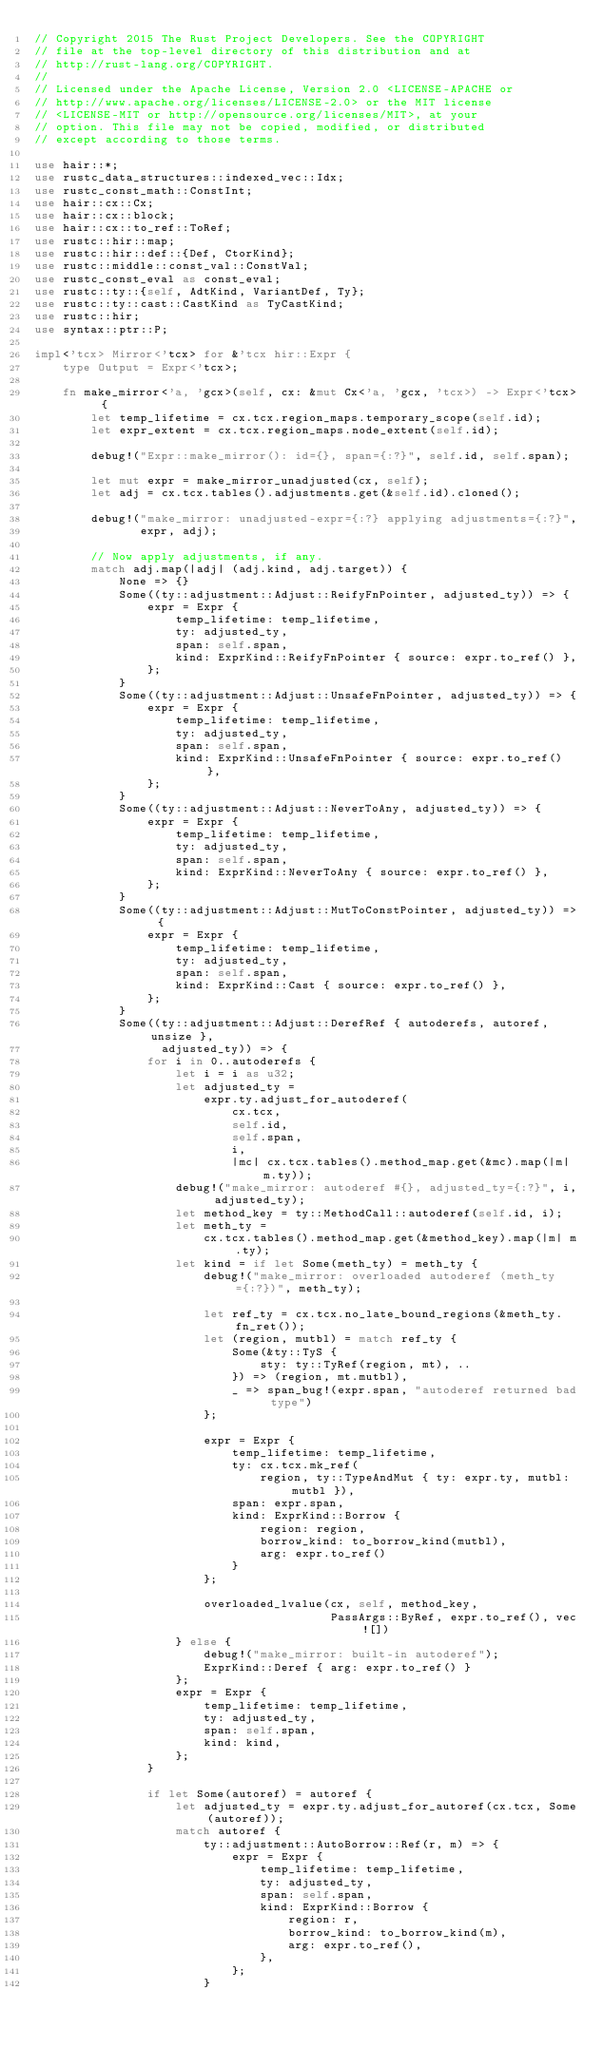Convert code to text. <code><loc_0><loc_0><loc_500><loc_500><_Rust_>// Copyright 2015 The Rust Project Developers. See the COPYRIGHT
// file at the top-level directory of this distribution and at
// http://rust-lang.org/COPYRIGHT.
//
// Licensed under the Apache License, Version 2.0 <LICENSE-APACHE or
// http://www.apache.org/licenses/LICENSE-2.0> or the MIT license
// <LICENSE-MIT or http://opensource.org/licenses/MIT>, at your
// option. This file may not be copied, modified, or distributed
// except according to those terms.

use hair::*;
use rustc_data_structures::indexed_vec::Idx;
use rustc_const_math::ConstInt;
use hair::cx::Cx;
use hair::cx::block;
use hair::cx::to_ref::ToRef;
use rustc::hir::map;
use rustc::hir::def::{Def, CtorKind};
use rustc::middle::const_val::ConstVal;
use rustc_const_eval as const_eval;
use rustc::ty::{self, AdtKind, VariantDef, Ty};
use rustc::ty::cast::CastKind as TyCastKind;
use rustc::hir;
use syntax::ptr::P;

impl<'tcx> Mirror<'tcx> for &'tcx hir::Expr {
    type Output = Expr<'tcx>;

    fn make_mirror<'a, 'gcx>(self, cx: &mut Cx<'a, 'gcx, 'tcx>) -> Expr<'tcx> {
        let temp_lifetime = cx.tcx.region_maps.temporary_scope(self.id);
        let expr_extent = cx.tcx.region_maps.node_extent(self.id);

        debug!("Expr::make_mirror(): id={}, span={:?}", self.id, self.span);

        let mut expr = make_mirror_unadjusted(cx, self);
        let adj = cx.tcx.tables().adjustments.get(&self.id).cloned();

        debug!("make_mirror: unadjusted-expr={:?} applying adjustments={:?}",
               expr, adj);

        // Now apply adjustments, if any.
        match adj.map(|adj| (adj.kind, adj.target)) {
            None => {}
            Some((ty::adjustment::Adjust::ReifyFnPointer, adjusted_ty)) => {
                expr = Expr {
                    temp_lifetime: temp_lifetime,
                    ty: adjusted_ty,
                    span: self.span,
                    kind: ExprKind::ReifyFnPointer { source: expr.to_ref() },
                };
            }
            Some((ty::adjustment::Adjust::UnsafeFnPointer, adjusted_ty)) => {
                expr = Expr {
                    temp_lifetime: temp_lifetime,
                    ty: adjusted_ty,
                    span: self.span,
                    kind: ExprKind::UnsafeFnPointer { source: expr.to_ref() },
                };
            }
            Some((ty::adjustment::Adjust::NeverToAny, adjusted_ty)) => {
                expr = Expr {
                    temp_lifetime: temp_lifetime,
                    ty: adjusted_ty,
                    span: self.span,
                    kind: ExprKind::NeverToAny { source: expr.to_ref() },
                };
            }
            Some((ty::adjustment::Adjust::MutToConstPointer, adjusted_ty)) => {
                expr = Expr {
                    temp_lifetime: temp_lifetime,
                    ty: adjusted_ty,
                    span: self.span,
                    kind: ExprKind::Cast { source: expr.to_ref() },
                };
            }
            Some((ty::adjustment::Adjust::DerefRef { autoderefs, autoref, unsize },
                  adjusted_ty)) => {
                for i in 0..autoderefs {
                    let i = i as u32;
                    let adjusted_ty =
                        expr.ty.adjust_for_autoderef(
                            cx.tcx,
                            self.id,
                            self.span,
                            i,
                            |mc| cx.tcx.tables().method_map.get(&mc).map(|m| m.ty));
                    debug!("make_mirror: autoderef #{}, adjusted_ty={:?}", i, adjusted_ty);
                    let method_key = ty::MethodCall::autoderef(self.id, i);
                    let meth_ty =
                        cx.tcx.tables().method_map.get(&method_key).map(|m| m.ty);
                    let kind = if let Some(meth_ty) = meth_ty {
                        debug!("make_mirror: overloaded autoderef (meth_ty={:?})", meth_ty);

                        let ref_ty = cx.tcx.no_late_bound_regions(&meth_ty.fn_ret());
                        let (region, mutbl) = match ref_ty {
                            Some(&ty::TyS {
                                sty: ty::TyRef(region, mt), ..
                            }) => (region, mt.mutbl),
                            _ => span_bug!(expr.span, "autoderef returned bad type")
                        };

                        expr = Expr {
                            temp_lifetime: temp_lifetime,
                            ty: cx.tcx.mk_ref(
                                region, ty::TypeAndMut { ty: expr.ty, mutbl: mutbl }),
                            span: expr.span,
                            kind: ExprKind::Borrow {
                                region: region,
                                borrow_kind: to_borrow_kind(mutbl),
                                arg: expr.to_ref()
                            }
                        };

                        overloaded_lvalue(cx, self, method_key,
                                          PassArgs::ByRef, expr.to_ref(), vec![])
                    } else {
                        debug!("make_mirror: built-in autoderef");
                        ExprKind::Deref { arg: expr.to_ref() }
                    };
                    expr = Expr {
                        temp_lifetime: temp_lifetime,
                        ty: adjusted_ty,
                        span: self.span,
                        kind: kind,
                    };
                }

                if let Some(autoref) = autoref {
                    let adjusted_ty = expr.ty.adjust_for_autoref(cx.tcx, Some(autoref));
                    match autoref {
                        ty::adjustment::AutoBorrow::Ref(r, m) => {
                            expr = Expr {
                                temp_lifetime: temp_lifetime,
                                ty: adjusted_ty,
                                span: self.span,
                                kind: ExprKind::Borrow {
                                    region: r,
                                    borrow_kind: to_borrow_kind(m),
                                    arg: expr.to_ref(),
                                },
                            };
                        }</code> 